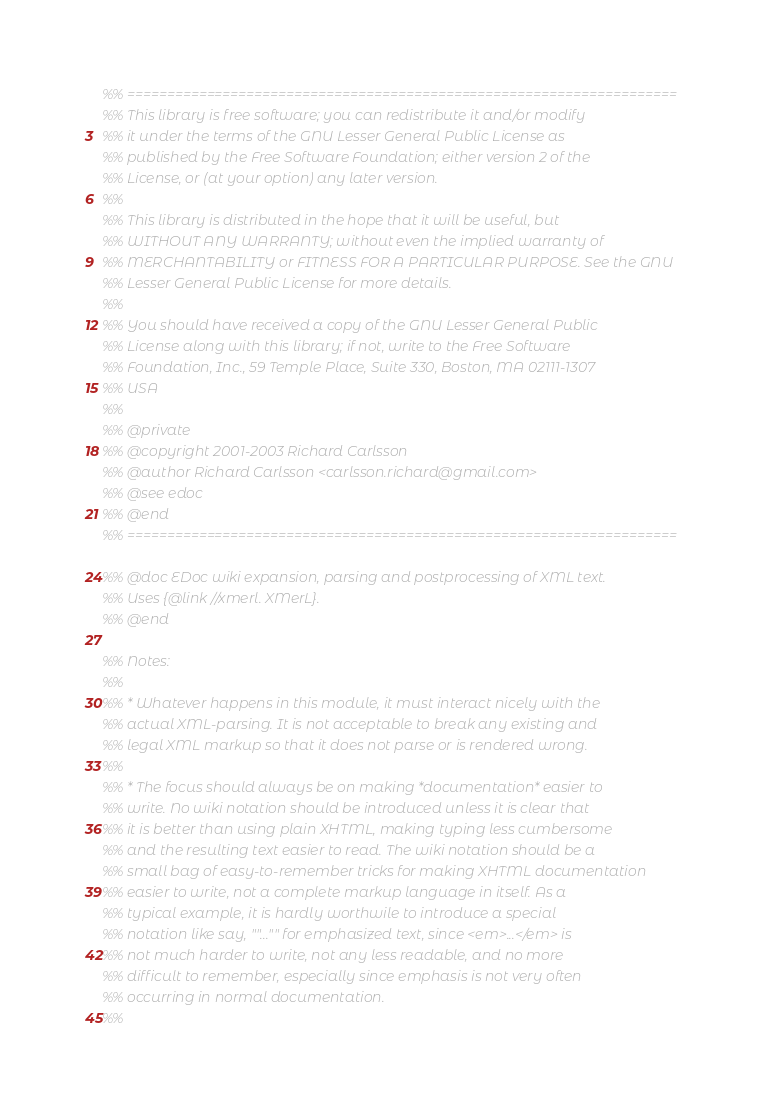<code> <loc_0><loc_0><loc_500><loc_500><_Erlang_>%% =====================================================================
%% This library is free software; you can redistribute it and/or modify
%% it under the terms of the GNU Lesser General Public License as
%% published by the Free Software Foundation; either version 2 of the
%% License, or (at your option) any later version.
%%
%% This library is distributed in the hope that it will be useful, but
%% WITHOUT ANY WARRANTY; without even the implied warranty of
%% MERCHANTABILITY or FITNESS FOR A PARTICULAR PURPOSE. See the GNU
%% Lesser General Public License for more details.
%%
%% You should have received a copy of the GNU Lesser General Public
%% License along with this library; if not, write to the Free Software
%% Foundation, Inc., 59 Temple Place, Suite 330, Boston, MA 02111-1307
%% USA
%%
%% @private
%% @copyright 2001-2003 Richard Carlsson
%% @author Richard Carlsson <carlsson.richard@gmail.com>
%% @see edoc
%% @end
%% =====================================================================

%% @doc EDoc wiki expansion, parsing and postprocessing of XML text.
%% Uses {@link //xmerl. XMerL}.
%% @end

%% Notes:
%%
%% * Whatever happens in this module, it must interact nicely with the
%% actual XML-parsing. It is not acceptable to break any existing and
%% legal XML markup so that it does not parse or is rendered wrong.
%%
%% * The focus should always be on making *documentation* easier to
%% write. No wiki notation should be introduced unless it is clear that
%% it is better than using plain XHTML, making typing less cumbersome
%% and the resulting text easier to read. The wiki notation should be a
%% small bag of easy-to-remember tricks for making XHTML documentation
%% easier to write, not a complete markup language in itself. As a
%% typical example, it is hardly worthwile to introduce a special
%% notation like say, ""..."" for emphasized text, since <em>...</em> is
%% not much harder to write, not any less readable, and no more
%% difficult to remember, especially since emphasis is not very often
%% occurring in normal documentation.
%%</code> 